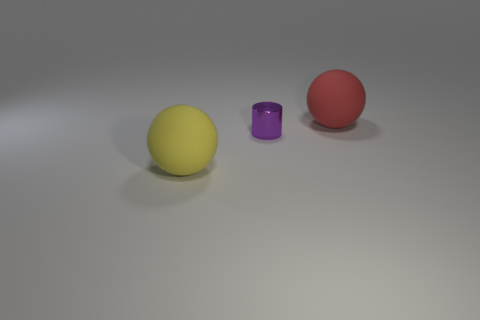Add 1 large matte objects. How many objects exist? 4 Subtract all cylinders. How many objects are left? 2 Subtract all red rubber balls. Subtract all large red spheres. How many objects are left? 1 Add 3 red matte balls. How many red matte balls are left? 4 Add 2 large yellow things. How many large yellow things exist? 3 Subtract 0 red cylinders. How many objects are left? 3 